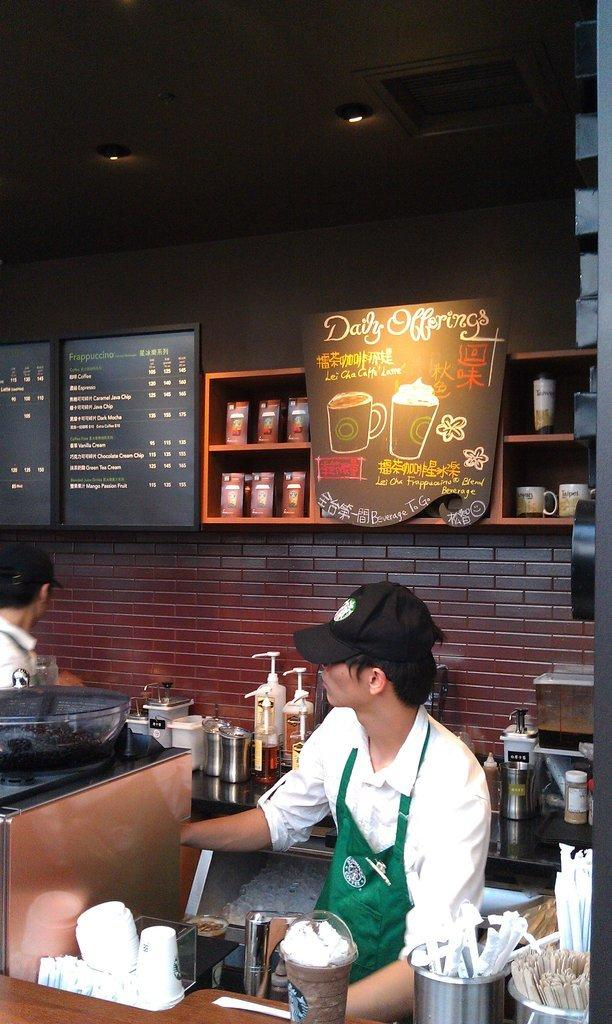<image>
Render a clear and concise summary of the photo. A daily offerings sign is on the wall behind the barista. 